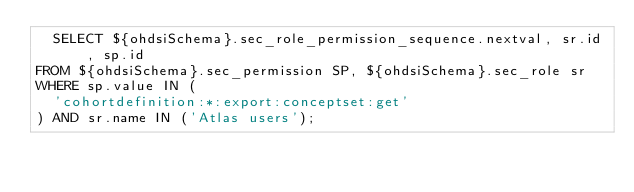Convert code to text. <code><loc_0><loc_0><loc_500><loc_500><_SQL_>  SELECT ${ohdsiSchema}.sec_role_permission_sequence.nextval, sr.id, sp.id
FROM ${ohdsiSchema}.sec_permission SP, ${ohdsiSchema}.sec_role sr
WHERE sp.value IN (
  'cohortdefinition:*:export:conceptset:get'
) AND sr.name IN ('Atlas users');</code> 